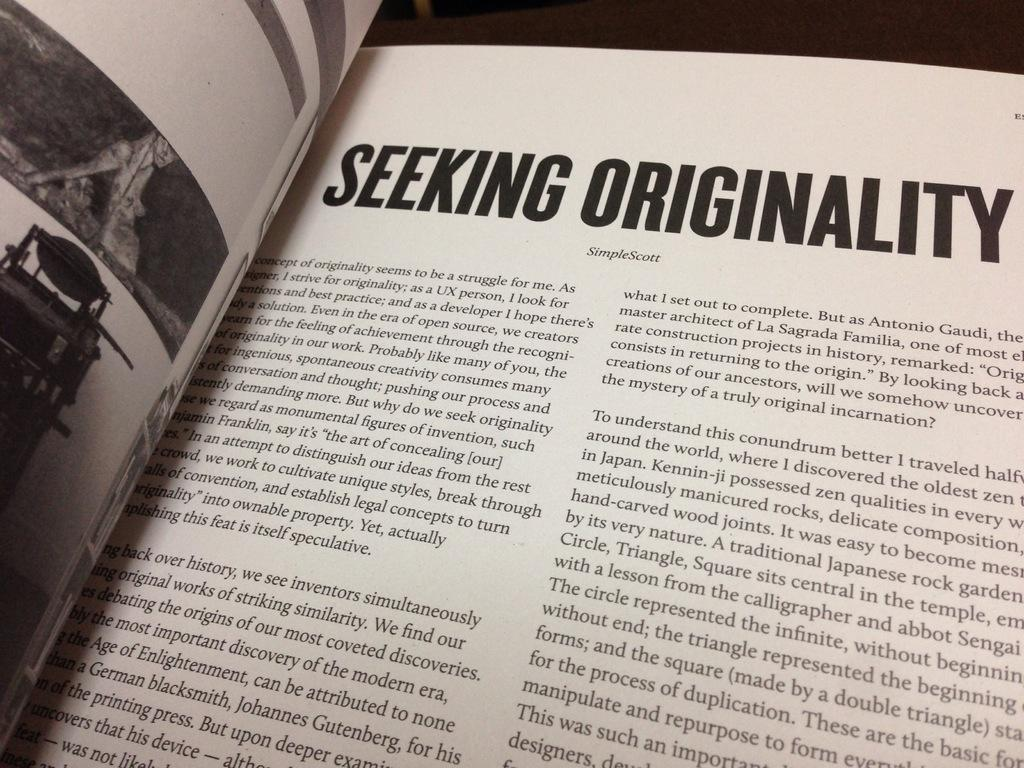Provide a one-sentence caption for the provided image. A book opened to a page with Seeking originality written on it. 